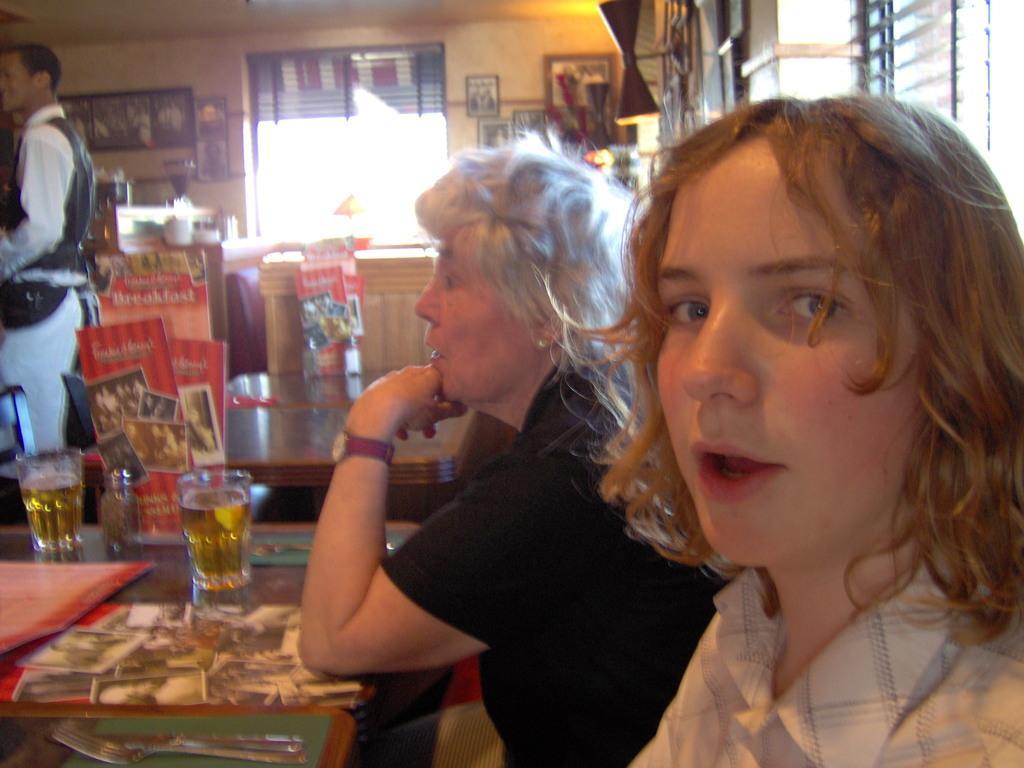How would you summarize this image in a sentence or two? This image is taken indoors. At the top of the image there is a roof. In the background there is a wall with many picture frames and windows. There are two window blinds. There is a table with a few objects on it. On the left side of the image there is a man standing on the floor. There is a table with two glasses of wine, a fork, a knife and a few things on it. There is a chair. There are a few boards with text and a few images on them. In the middle of the image there is an empty table. On the right side of the image two women are sitting in the chairs. 